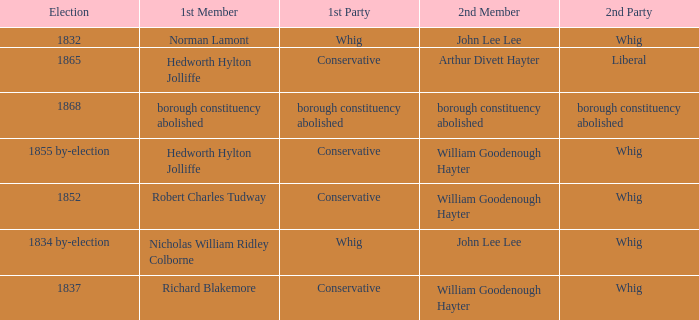What election has a 1st member of richard blakemore and a 2nd member of william goodenough hayter? 1837.0. 